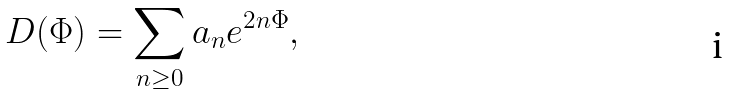<formula> <loc_0><loc_0><loc_500><loc_500>D ( \Phi ) = \sum _ { n \geq 0 } a _ { n } e ^ { 2 n \Phi } ,</formula> 